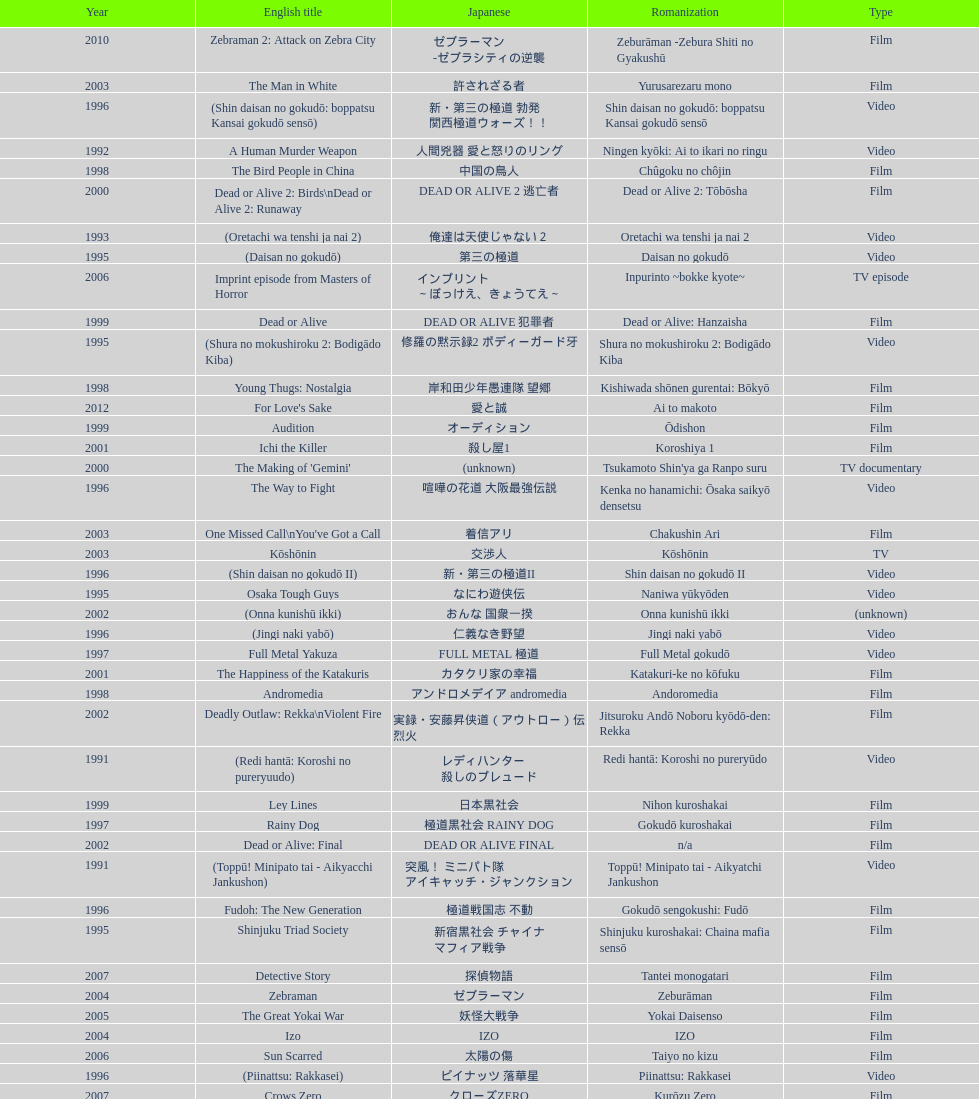Give me the full table as a dictionary. {'header': ['Year', 'English title', 'Japanese', 'Romanization', 'Type'], 'rows': [['2010', 'Zebraman 2: Attack on Zebra City', 'ゼブラーマン -ゼブラシティの逆襲', 'Zeburāman -Zebura Shiti no Gyakushū', 'Film'], ['2003', 'The Man in White', '許されざる者', 'Yurusarezaru mono', 'Film'], ['1996', '(Shin daisan no gokudō: boppatsu Kansai gokudō sensō)', '新・第三の極道 勃発 関西極道ウォーズ！！', 'Shin daisan no gokudō: boppatsu Kansai gokudō sensō', 'Video'], ['1992', 'A Human Murder Weapon', '人間兇器 愛と怒りのリング', 'Ningen kyōki: Ai to ikari no ringu', 'Video'], ['1998', 'The Bird People in China', '中国の鳥人', 'Chûgoku no chôjin', 'Film'], ['2000', 'Dead or Alive 2: Birds\\nDead or Alive 2: Runaway', 'DEAD OR ALIVE 2 逃亡者', 'Dead or Alive 2: Tōbōsha', 'Film'], ['1993', '(Oretachi wa tenshi ja nai 2)', '俺達は天使じゃない２', 'Oretachi wa tenshi ja nai 2', 'Video'], ['1995', '(Daisan no gokudō)', '第三の極道', 'Daisan no gokudō', 'Video'], ['2006', 'Imprint episode from Masters of Horror', 'インプリント ～ぼっけえ、きょうてえ～', 'Inpurinto ~bokke kyote~', 'TV episode'], ['1999', 'Dead or Alive', 'DEAD OR ALIVE 犯罪者', 'Dead or Alive: Hanzaisha', 'Film'], ['1995', '(Shura no mokushiroku 2: Bodigādo Kiba)', '修羅の黙示録2 ボディーガード牙', 'Shura no mokushiroku 2: Bodigādo Kiba', 'Video'], ['1998', 'Young Thugs: Nostalgia', '岸和田少年愚連隊 望郷', 'Kishiwada shōnen gurentai: Bōkyō', 'Film'], ['2012', "For Love's Sake", '愛と誠', 'Ai to makoto', 'Film'], ['1999', 'Audition', 'オーディション', 'Ōdishon', 'Film'], ['2001', 'Ichi the Killer', '殺し屋1', 'Koroshiya 1', 'Film'], ['2000', "The Making of 'Gemini'", '(unknown)', "Tsukamoto Shin'ya ga Ranpo suru", 'TV documentary'], ['1996', 'The Way to Fight', '喧嘩の花道 大阪最強伝説', 'Kenka no hanamichi: Ōsaka saikyō densetsu', 'Video'], ['2003', "One Missed Call\\nYou've Got a Call", '着信アリ', 'Chakushin Ari', 'Film'], ['2003', 'Kōshōnin', '交渉人', 'Kōshōnin', 'TV'], ['1996', '(Shin daisan no gokudō II)', '新・第三の極道II', 'Shin daisan no gokudō II', 'Video'], ['1995', 'Osaka Tough Guys', 'なにわ遊侠伝', 'Naniwa yūkyōden', 'Video'], ['2002', '(Onna kunishū ikki)', 'おんな 国衆一揆', 'Onna kunishū ikki', '(unknown)'], ['1996', '(Jingi naki yabō)', '仁義なき野望', 'Jingi naki yabō', 'Video'], ['1997', 'Full Metal Yakuza', 'FULL METAL 極道', 'Full Metal gokudō', 'Video'], ['2001', 'The Happiness of the Katakuris', 'カタクリ家の幸福', 'Katakuri-ke no kōfuku', 'Film'], ['1998', 'Andromedia', 'アンドロメデイア andromedia', 'Andoromedia', 'Film'], ['2002', 'Deadly Outlaw: Rekka\\nViolent Fire', '実録・安藤昇侠道（アウトロー）伝 烈火', 'Jitsuroku Andō Noboru kyōdō-den: Rekka', 'Film'], ['1991', '(Redi hantā: Koroshi no pureryuudo)', 'レディハンター 殺しのプレュード', 'Redi hantā: Koroshi no pureryūdo', 'Video'], ['1999', 'Ley Lines', '日本黒社会', 'Nihon kuroshakai', 'Film'], ['1997', 'Rainy Dog', '極道黒社会 RAINY DOG', 'Gokudō kuroshakai', 'Film'], ['2002', 'Dead or Alive: Final', 'DEAD OR ALIVE FINAL', 'n/a', 'Film'], ['1991', '(Toppū! Minipato tai - Aikyacchi Jankushon)', '突風！ ミニパト隊 アイキャッチ・ジャンクション', 'Toppū! Minipato tai - Aikyatchi Jankushon', 'Video'], ['1996', 'Fudoh: The New Generation', '極道戦国志 不動', 'Gokudō sengokushi: Fudō', 'Film'], ['1995', 'Shinjuku Triad Society', '新宿黒社会 チャイナ マフィア戦争', 'Shinjuku kuroshakai: Chaina mafia sensō', 'Film'], ['2007', 'Detective Story', '探偵物語', 'Tantei monogatari', 'Film'], ['2004', 'Zebraman', 'ゼブラーマン', 'Zeburāman', 'Film'], ['2005', 'The Great Yokai War', '妖怪大戦争', 'Yokai Daisenso', 'Film'], ['2004', 'Izo', 'IZO', 'IZO', 'Film'], ['2006', 'Sun Scarred', '太陽の傷', 'Taiyo no kizu', 'Film'], ['1996', '(Piinattsu: Rakkasei)', 'ピイナッツ 落華星', 'Piinattsu: Rakkasei', 'Video'], ['2007', 'Crows Zero', 'クローズZERO', 'Kurōzu Zero', 'Film'], ['2009', 'Crows Zero 2', 'クローズZERO 2', 'Kurōzu Zero 2', 'Film'], ['2002', 'Shangri-La', '金融破滅ニッポン 桃源郷の人々', "Kin'yū hametsu Nippon: Tōgenkyō no hito-bito", 'Film'], ['1998', 'Blues Harp', 'BLUES HARP', 'n/a', 'Film'], ['2012', 'Lesson of the Evil', '悪の教典', 'Aku no Kyōten', 'Film'], ['2002', 'Pandōra', 'パンドーラ', 'Pandōra', 'Music video'], ['2000', 'The Guys from Paradise', '天国から来た男たち', 'Tengoku kara kita otoko-tachi', 'Film'], ['1994', '(Shura no mokushiroku: Bodigādo Kiba)', '修羅の黙示録 ボディーガード牙', 'Shura no mokushiroku: Bodigādo Kiba', 'Video'], ['1999', 'Man, Next Natural Girl: 100 Nights In Yokohama\\nN-Girls vs Vampire', '天然少女萬NEXT 横浜百夜篇', 'Tennen shōjo Man next: Yokohama hyaku-ya hen', 'TV'], ['2000', 'MPD Psycho', '多重人格探偵サイコ', 'Tajū jinkaku tantei saiko: Amamiya Kazuhiko no kikan', 'TV miniseries'], ['2001', 'Family', 'FAMILY', 'n/a', 'Film'], ['2001', '(Zuiketsu gensō: Tonkararin yume densetsu)', '隧穴幻想 トンカラリン夢伝説', 'Zuiketsu gensō: Tonkararin yume densetsu', 'Film'], ['2002', 'Sabu', 'SABU さぶ', 'Sabu', 'TV'], ['1993', 'Bodyguard Kiba', 'ボディガード牙', 'Bodigādo Kiba', 'Video'], ['2008', "God's Puzzle", '神様のパズル', 'Kamisama no pazuru', 'Film'], ['1997', 'Young Thugs: Innocent Blood', '岸和田少年愚連隊 血煙り純情篇', 'Kishiwada shōnen gurentai: Chikemuri junjō-hen', 'Film'], ['2002', 'Graveyard of Honor', '新・仁義の墓場', 'Shin jingi no hakaba', 'Film'], ['2007', 'Zatoichi', '座頭市', 'Zatōichi', 'Stageplay'], ['2007', 'Like a Dragon', '龍が如く 劇場版', 'Ryu ga Gotoku Gekijōban', 'Film'], ['2010', 'Thirteen Assassins', '十三人の刺客', 'Jûsan-nin no shikaku', 'Film'], ['2003', 'Yakuza Demon', '鬼哭 kikoku', 'Kikoku', 'Video'], ['2001', 'Agitator', '荒ぶる魂たち', 'Araburu tamashii-tachi', 'Film'], ['2000', 'The City of Lost Souls\\nThe City of Strangers\\nThe Hazard City', '漂流街 THE HAZARD CITY', 'Hyōryū-gai', 'Film'], ['2009', 'Yatterman', 'ヤッターマン', 'Yattaaman', 'Film'], ['2006', 'Waru', 'WARU', 'Waru', 'Film'], ['2002', 'Pāto-taimu tantei', 'パートタイム探偵', 'Pāto-taimu tantei', 'TV series'], ['2011', 'Ninja Kids!!!', '忍たま乱太郎', 'Nintama Rantarō', 'Film'], ['2013', 'Shield of Straw', '藁の楯', 'Wara no Tate', 'Film'], ['2004', 'Pāto-taimu tantei 2', 'パートタイム探偵2', 'Pāto-taimu tantei 2', 'TV'], ['2013', 'The Mole Song: Undercover Agent Reiji', '土竜の唄\u3000潜入捜査官 REIJI', 'Mogura no uta – sennyu sosakan: Reiji', 'Film'], ['2012', 'Ace Attorney', '逆転裁判', 'Gyakuten Saiban', 'Film'], ['1999', 'Man, A Natural Girl', '天然少女萬', 'Tennen shōjo Man', 'TV'], ['2001', '(Kikuchi-jō monogatari: sakimori-tachi no uta)', '鞠智城物語 防人たちの唄', 'Kikuchi-jō monogatari: sakimori-tachi no uta', 'Film'], ['2004', 'Box segment in Three... Extremes', 'BOX（『美しい夜、残酷な朝』）', 'Saam gaang yi', 'Segment in feature film'], ['2011', 'Hara-Kiri: Death of a Samurai', '一命', 'Ichimei', 'Film'], ['1991', '(Shissō Feraari 250 GTO / Rasuto ran: Ai to uragiri no hyaku-oku en)', '疾走フェラーリ250GTO/ラスト・ラン～愛と裏切りの百億円', 'Shissō Feraari 250 GTO / Rasuto ran: Ai to uragiri no hyaku-oku en\\nShissō Feraari 250 GTO / Rasuto ran: Ai to uragiri no ¥10 000 000 000', 'TV'], ['2005', 'Ultraman Max', 'ウルトラマンマックス', 'Urutoraman Makkusu', 'Episodes 15 and 16 from TV tokusatsu series'], ['2003', 'Gozu', '極道恐怖大劇場 牛頭 GOZU', 'Gokudō kyōfu dai-gekijō: Gozu', 'Film'], ['2006', 'Big Bang Love, Juvenile A\\n4.6 Billion Years of Love', '46億年の恋', '46-okunen no koi', 'Film'], ['2008', 'K-tai Investigator 7', 'ケータイ捜査官7', 'Keitai Sōsakan 7', 'TV'], ['1999', 'Silver', 'シルバー SILVER', 'Silver: shirubā', 'Video'], ['1994', 'Shinjuku Outlaw', '新宿アウトロー', 'Shinjuku autorou', 'Video'], ['1993', '(Oretachi wa tenshi ja nai)', '俺達は天使じゃない', 'Oretachi wa tenshi ja nai', 'Video'], ['2001', 'Visitor Q', 'ビジターQ', 'Bijitā Q', 'Video'], ['2006', 'Waru: kanketsu-hen', '', 'Waru: kanketsu-hen', 'Video'], ['1999', 'Salaryman Kintaro\\nWhite Collar Worker Kintaro', 'サラリーマン金太郎', 'Sarariiman Kintarō', 'Film'], ['1997', '(Jingi naki yabō 2)', '仁義なき野望2', 'Jingi naki yabō 2', 'Video'], ['2007', 'Sukiyaki Western Django', 'スキヤキ・ウエスタン ジャンゴ', 'Sukiyaki wesutān jango', 'Film']]} What is a movie that was launched before the year 1996? Shinjuku Triad Society. 